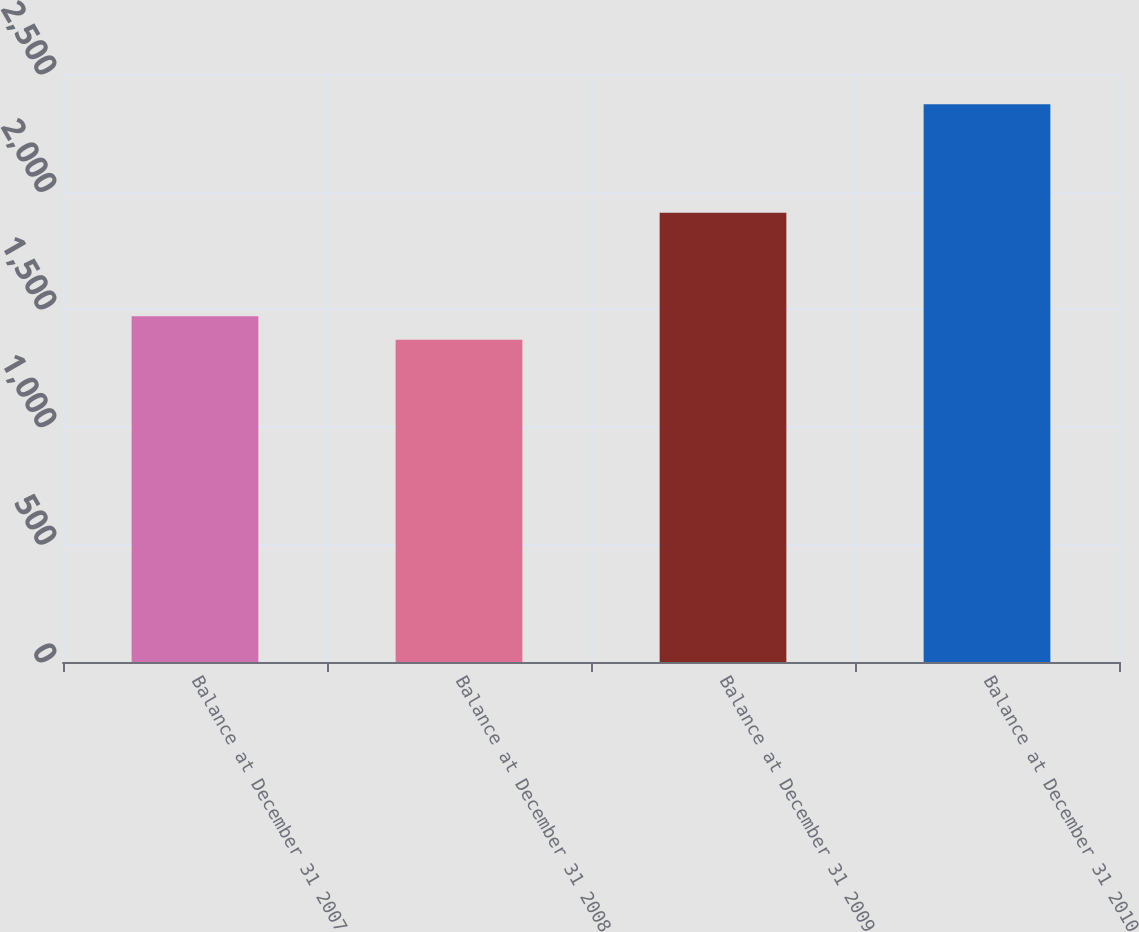Convert chart to OTSL. <chart><loc_0><loc_0><loc_500><loc_500><bar_chart><fcel>Balance at December 31 2007<fcel>Balance at December 31 2008<fcel>Balance at December 31 2009<fcel>Balance at December 31 2010<nl><fcel>1470.1<fcel>1370<fcel>1910<fcel>2371<nl></chart> 